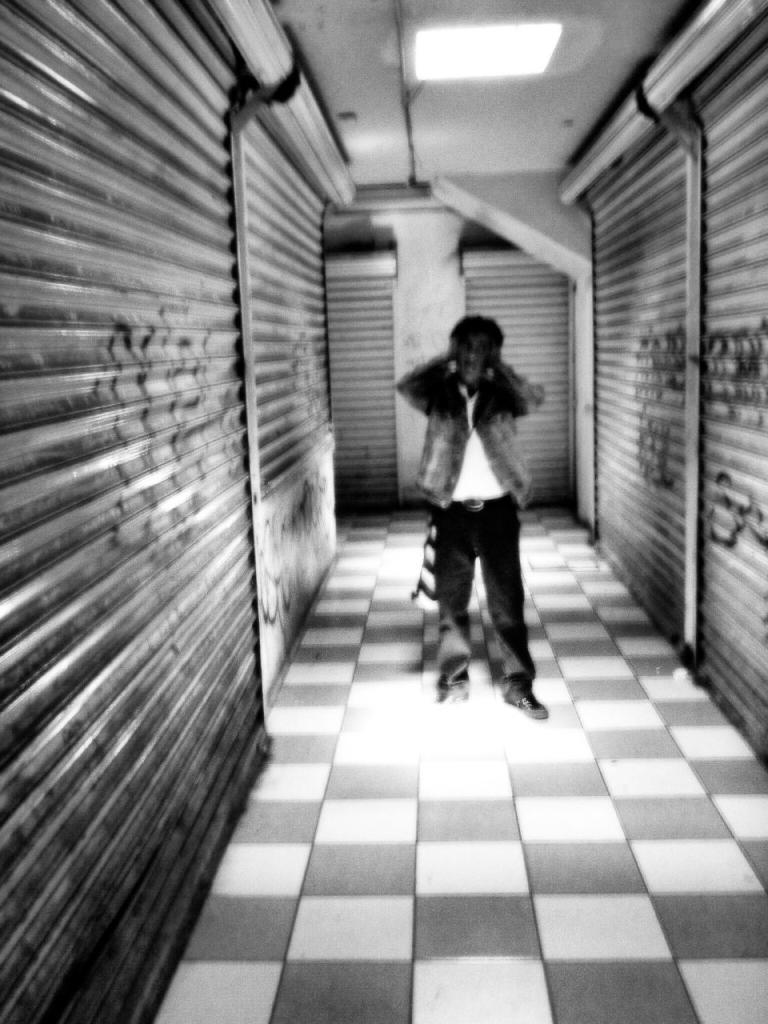What is the main subject of the image? There is a person standing in the image. What is the color scheme of the image? The image is in black and white. What architectural feature can be seen in the background of the image? There are shutters visible in the background of the image. How many ladybugs can be seen on the person's shoulder in the image? There are no ladybugs present in the image. What type of bulb is illuminating the scene in the image? The image is in black and white, so it is not possible to determine if any bulbs are present or their type. 